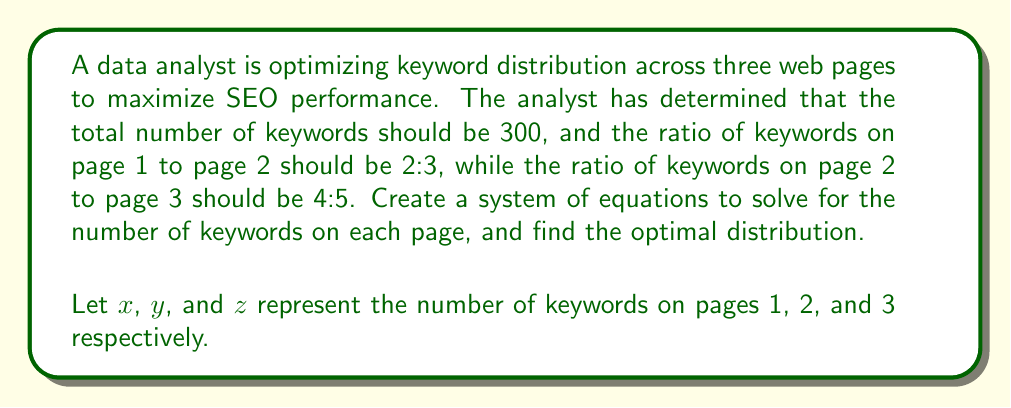Can you answer this question? To solve this problem, we need to create a system of equations based on the given information:

1. Total number of keywords:
   $$x + y + z = 300$$

2. Ratio of keywords on page 1 to page 2 (2:3):
   $$\frac{x}{y} = \frac{2}{3}$$
   This can be rewritten as: $$3x = 2y$$

3. Ratio of keywords on page 2 to page 3 (4:5):
   $$\frac{y}{z} = \frac{4}{5}$$
   This can be rewritten as: $$5y = 4z$$

Now we have a system of three equations with three unknowns:

$$\begin{cases}
x + y + z = 300 \\
3x = 2y \\
5y = 4z
\end{cases}$$

To solve this system:

1. From the second equation: $x = \frac{2y}{3}$
2. From the third equation: $z = \frac{5y}{4}$
3. Substitute these into the first equation:

   $$\frac{2y}{3} + y + \frac{5y}{4} = 300$$

4. Multiply all terms by 12 to eliminate fractions:

   $$8y + 12y + 15y = 3600$$
   $$35y = 3600$$

5. Solve for y:

   $$y = \frac{3600}{35} = 102.86$$

   Since we can't have fractional keywords, we round to the nearest integer: $y = 103$

6. Now we can solve for x and z:

   $$x = \frac{2y}{3} = \frac{2(103)}{3} = 68.67 \approx 69$$
   $$z = \frac{5y}{4} = \frac{5(103)}{4} = 128.75 \approx 129$$

7. Check the total: $69 + 103 + 129 = 301$

   We need to adjust one value to get exactly 300 keywords. We'll decrease z by 1 to maintain the closest ratio.

Therefore, the optimal distribution of keywords is:
- Page 1 (x): 69 keywords
- Page 2 (y): 103 keywords
- Page 3 (z): 128 keywords
Answer: The optimal keyword distribution across the three web pages is:
Page 1: 69 keywords
Page 2: 103 keywords
Page 3: 128 keywords 